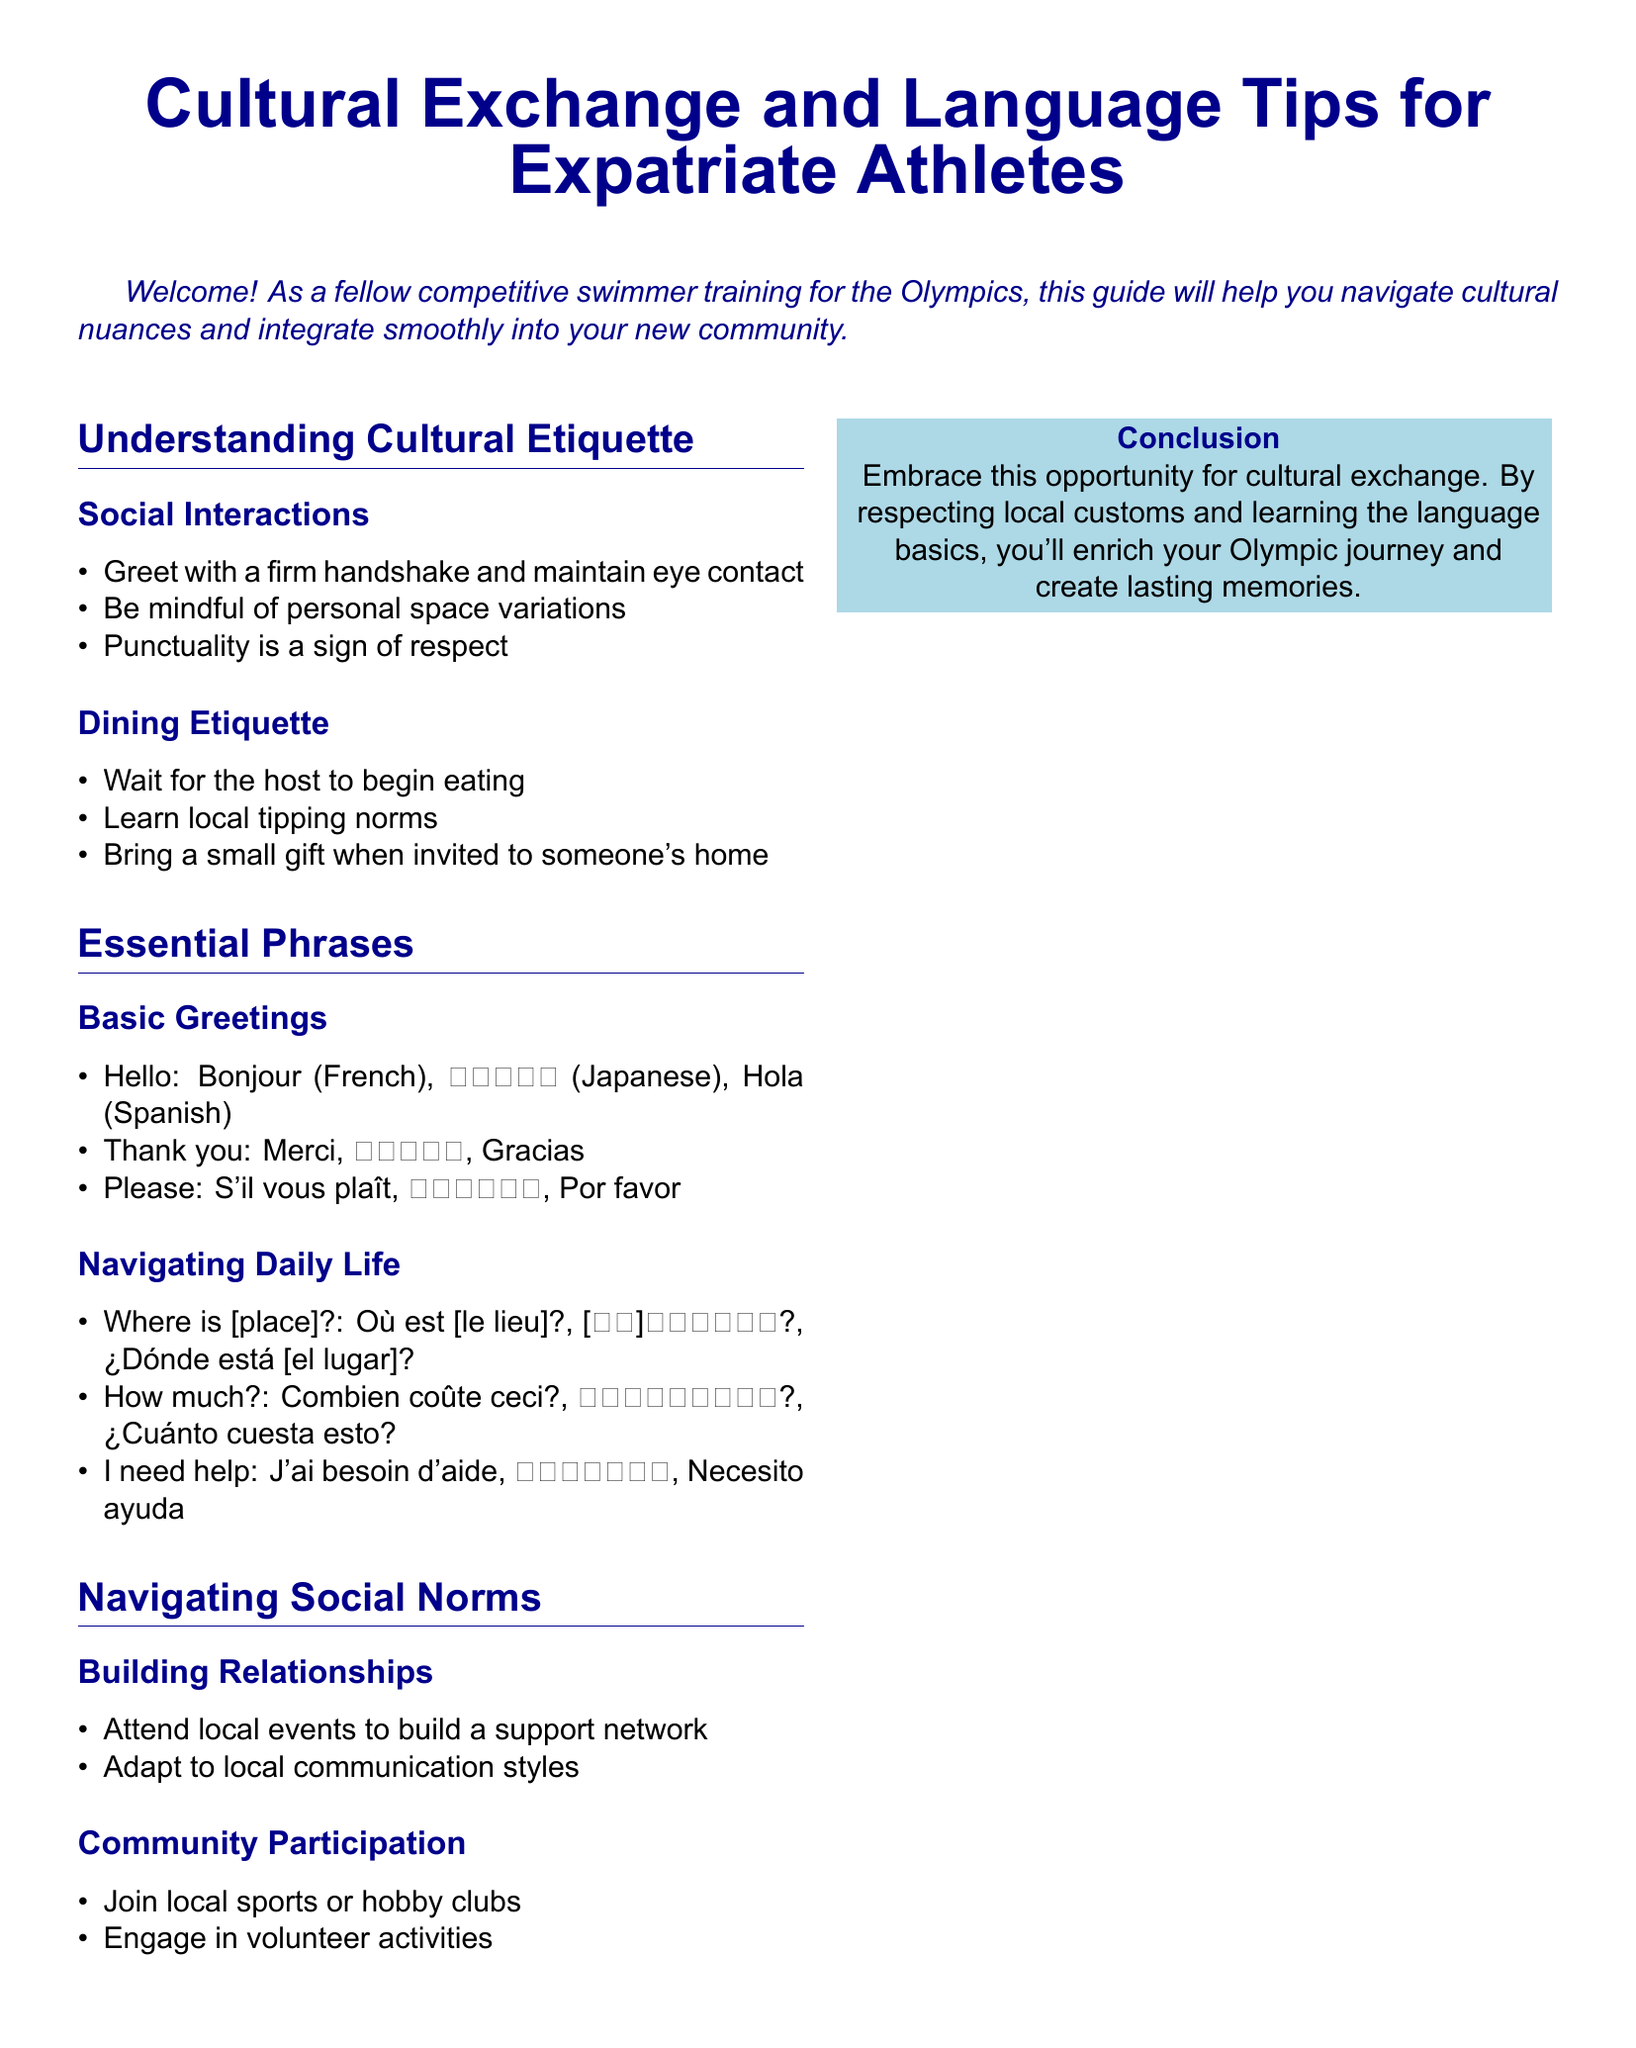What are the basic greetings listed? The document provides specific phrases for greetings, which include "Hello," "Thank you," and "Please" along with their translations.
Answer: Bonjour, こんにちは, Hola What should you do when invited to someone's home? The dining etiquette section mentions an action to take when invited to someone's home, which is to bring something.
Answer: A small gift What is a sign of respect in social interactions? The document states that being punctual is an important aspect of social etiquette.
Answer: Punctuality What phrase would you use to ask for help? Essential phrases include expressions for help, and one of them is to request assistance.
Answer: I need help What is one way to build relationships in the new community? The document suggests attending events as a method for building connections in a new place.
Answer: Attend local events How many sections are there in the document? The document consists of several clear sections that categorize information for expatriate athletes.
Answer: Three What do you learn about community participation? The document mentions involvement in specific activities as a means of engaging with the local community.
Answer: Join local sports or hobby clubs What is a common dining etiquette rule mentioned? One part of dining etiquette involves when to start eating in relation to the host.
Answer: Wait for the host to begin eating What language is "Thank you" in French? The document specifically lists translations for gratitude, one of which is in French.
Answer: Merci 